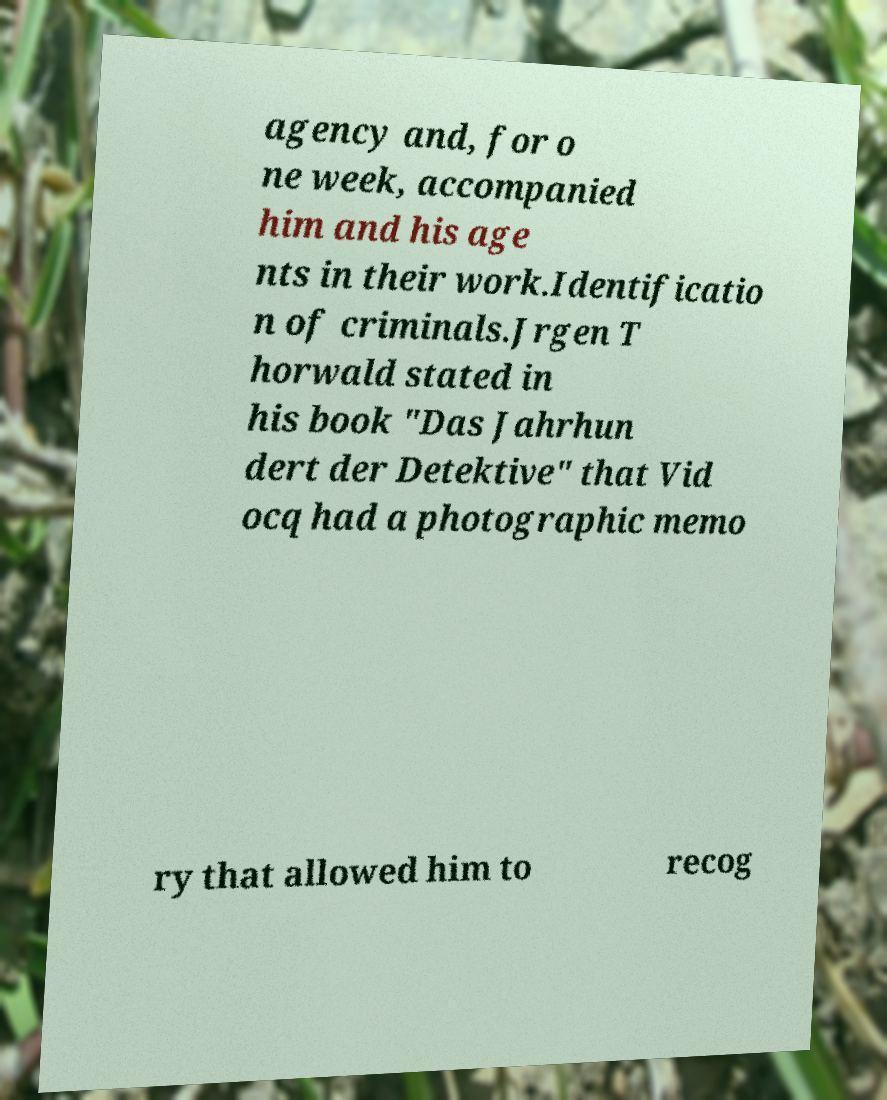There's text embedded in this image that I need extracted. Can you transcribe it verbatim? agency and, for o ne week, accompanied him and his age nts in their work.Identificatio n of criminals.Jrgen T horwald stated in his book "Das Jahrhun dert der Detektive" that Vid ocq had a photographic memo ry that allowed him to recog 